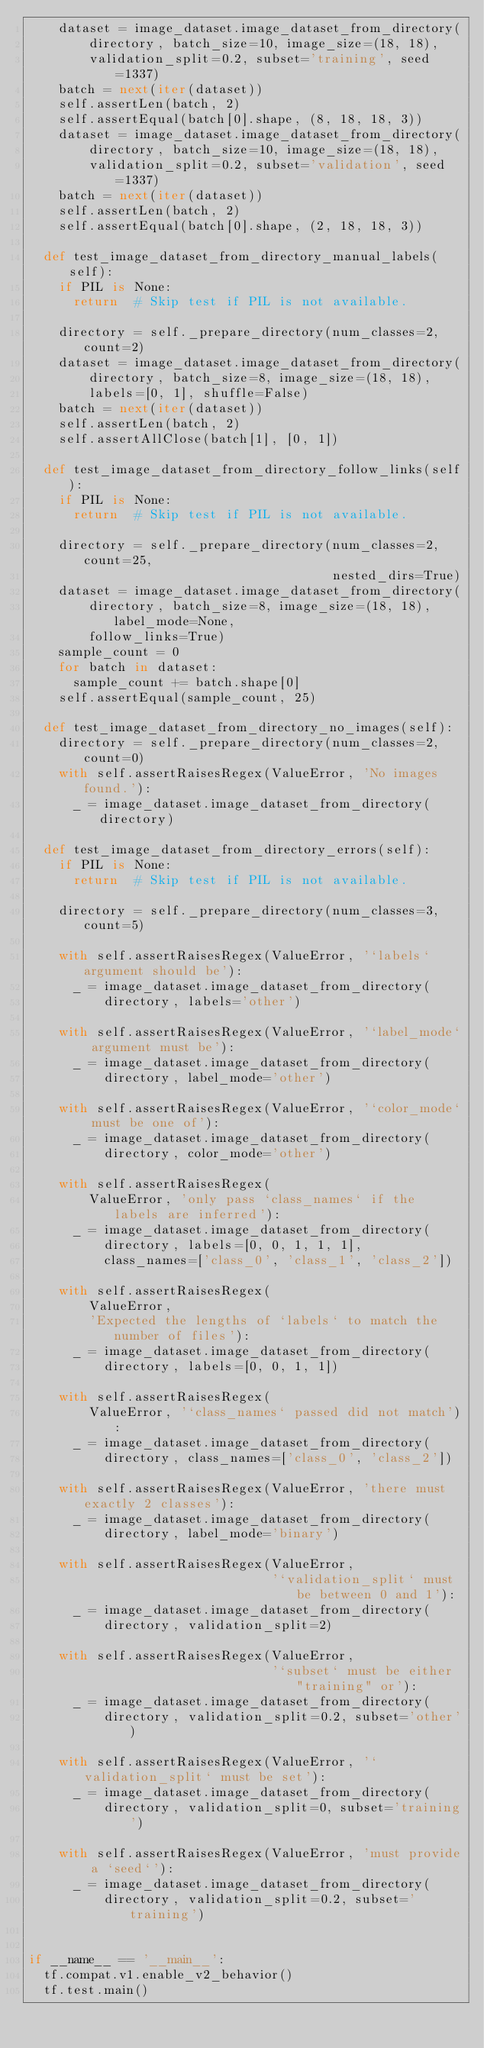<code> <loc_0><loc_0><loc_500><loc_500><_Python_>    dataset = image_dataset.image_dataset_from_directory(
        directory, batch_size=10, image_size=(18, 18),
        validation_split=0.2, subset='training', seed=1337)
    batch = next(iter(dataset))
    self.assertLen(batch, 2)
    self.assertEqual(batch[0].shape, (8, 18, 18, 3))
    dataset = image_dataset.image_dataset_from_directory(
        directory, batch_size=10, image_size=(18, 18),
        validation_split=0.2, subset='validation', seed=1337)
    batch = next(iter(dataset))
    self.assertLen(batch, 2)
    self.assertEqual(batch[0].shape, (2, 18, 18, 3))

  def test_image_dataset_from_directory_manual_labels(self):
    if PIL is None:
      return  # Skip test if PIL is not available.

    directory = self._prepare_directory(num_classes=2, count=2)
    dataset = image_dataset.image_dataset_from_directory(
        directory, batch_size=8, image_size=(18, 18),
        labels=[0, 1], shuffle=False)
    batch = next(iter(dataset))
    self.assertLen(batch, 2)
    self.assertAllClose(batch[1], [0, 1])

  def test_image_dataset_from_directory_follow_links(self):
    if PIL is None:
      return  # Skip test if PIL is not available.

    directory = self._prepare_directory(num_classes=2, count=25,
                                        nested_dirs=True)
    dataset = image_dataset.image_dataset_from_directory(
        directory, batch_size=8, image_size=(18, 18), label_mode=None,
        follow_links=True)
    sample_count = 0
    for batch in dataset:
      sample_count += batch.shape[0]
    self.assertEqual(sample_count, 25)

  def test_image_dataset_from_directory_no_images(self):
    directory = self._prepare_directory(num_classes=2, count=0)
    with self.assertRaisesRegex(ValueError, 'No images found.'):
      _ = image_dataset.image_dataset_from_directory(directory)

  def test_image_dataset_from_directory_errors(self):
    if PIL is None:
      return  # Skip test if PIL is not available.

    directory = self._prepare_directory(num_classes=3, count=5)

    with self.assertRaisesRegex(ValueError, '`labels` argument should be'):
      _ = image_dataset.image_dataset_from_directory(
          directory, labels='other')

    with self.assertRaisesRegex(ValueError, '`label_mode` argument must be'):
      _ = image_dataset.image_dataset_from_directory(
          directory, label_mode='other')

    with self.assertRaisesRegex(ValueError, '`color_mode` must be one of'):
      _ = image_dataset.image_dataset_from_directory(
          directory, color_mode='other')

    with self.assertRaisesRegex(
        ValueError, 'only pass `class_names` if the labels are inferred'):
      _ = image_dataset.image_dataset_from_directory(
          directory, labels=[0, 0, 1, 1, 1],
          class_names=['class_0', 'class_1', 'class_2'])

    with self.assertRaisesRegex(
        ValueError,
        'Expected the lengths of `labels` to match the number of files'):
      _ = image_dataset.image_dataset_from_directory(
          directory, labels=[0, 0, 1, 1])

    with self.assertRaisesRegex(
        ValueError, '`class_names` passed did not match'):
      _ = image_dataset.image_dataset_from_directory(
          directory, class_names=['class_0', 'class_2'])

    with self.assertRaisesRegex(ValueError, 'there must exactly 2 classes'):
      _ = image_dataset.image_dataset_from_directory(
          directory, label_mode='binary')

    with self.assertRaisesRegex(ValueError,
                                '`validation_split` must be between 0 and 1'):
      _ = image_dataset.image_dataset_from_directory(
          directory, validation_split=2)

    with self.assertRaisesRegex(ValueError,
                                '`subset` must be either "training" or'):
      _ = image_dataset.image_dataset_from_directory(
          directory, validation_split=0.2, subset='other')

    with self.assertRaisesRegex(ValueError, '`validation_split` must be set'):
      _ = image_dataset.image_dataset_from_directory(
          directory, validation_split=0, subset='training')

    with self.assertRaisesRegex(ValueError, 'must provide a `seed`'):
      _ = image_dataset.image_dataset_from_directory(
          directory, validation_split=0.2, subset='training')


if __name__ == '__main__':
  tf.compat.v1.enable_v2_behavior()
  tf.test.main()
</code> 